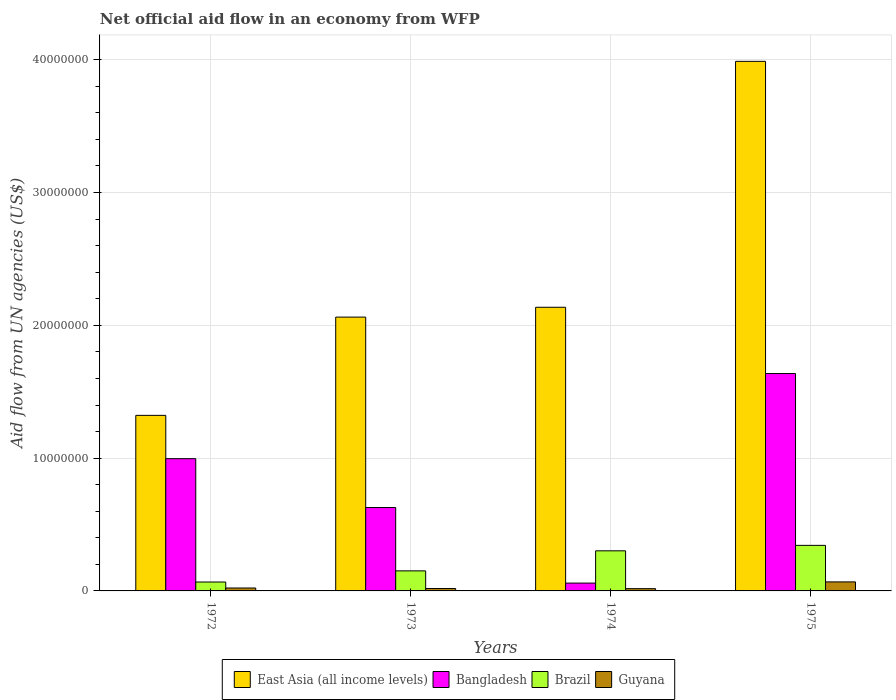Are the number of bars per tick equal to the number of legend labels?
Offer a terse response. Yes. In how many cases, is the number of bars for a given year not equal to the number of legend labels?
Keep it short and to the point. 0. What is the net official aid flow in Bangladesh in 1973?
Provide a succinct answer. 6.28e+06. Across all years, what is the maximum net official aid flow in Guyana?
Ensure brevity in your answer.  6.80e+05. Across all years, what is the minimum net official aid flow in Bangladesh?
Your answer should be very brief. 5.90e+05. In which year was the net official aid flow in Guyana maximum?
Offer a terse response. 1975. In which year was the net official aid flow in Bangladesh minimum?
Your answer should be compact. 1974. What is the total net official aid flow in Guyana in the graph?
Keep it short and to the point. 1.25e+06. What is the difference between the net official aid flow in Guyana in 1972 and that in 1973?
Give a very brief answer. 4.00e+04. What is the difference between the net official aid flow in East Asia (all income levels) in 1975 and the net official aid flow in Brazil in 1972?
Provide a short and direct response. 3.92e+07. What is the average net official aid flow in Bangladesh per year?
Keep it short and to the point. 8.30e+06. In the year 1975, what is the difference between the net official aid flow in East Asia (all income levels) and net official aid flow in Bangladesh?
Your answer should be very brief. 2.35e+07. In how many years, is the net official aid flow in East Asia (all income levels) greater than 38000000 US$?
Make the answer very short. 1. What is the ratio of the net official aid flow in East Asia (all income levels) in 1972 to that in 1975?
Make the answer very short. 0.33. Is the net official aid flow in Brazil in 1972 less than that in 1975?
Your answer should be compact. Yes. Is the difference between the net official aid flow in East Asia (all income levels) in 1972 and 1975 greater than the difference between the net official aid flow in Bangladesh in 1972 and 1975?
Keep it short and to the point. No. What is the difference between the highest and the second highest net official aid flow in Guyana?
Offer a very short reply. 4.60e+05. What is the difference between the highest and the lowest net official aid flow in Guyana?
Ensure brevity in your answer.  5.10e+05. In how many years, is the net official aid flow in Bangladesh greater than the average net official aid flow in Bangladesh taken over all years?
Ensure brevity in your answer.  2. What does the 4th bar from the left in 1973 represents?
Give a very brief answer. Guyana. What does the 1st bar from the right in 1972 represents?
Your answer should be very brief. Guyana. Are all the bars in the graph horizontal?
Offer a terse response. No. How many years are there in the graph?
Your answer should be compact. 4. What is the difference between two consecutive major ticks on the Y-axis?
Your response must be concise. 1.00e+07. Are the values on the major ticks of Y-axis written in scientific E-notation?
Provide a short and direct response. No. How many legend labels are there?
Your answer should be compact. 4. What is the title of the graph?
Your answer should be compact. Net official aid flow in an economy from WFP. Does "Singapore" appear as one of the legend labels in the graph?
Your answer should be very brief. No. What is the label or title of the Y-axis?
Offer a terse response. Aid flow from UN agencies (US$). What is the Aid flow from UN agencies (US$) of East Asia (all income levels) in 1972?
Offer a very short reply. 1.32e+07. What is the Aid flow from UN agencies (US$) in Bangladesh in 1972?
Your answer should be very brief. 9.96e+06. What is the Aid flow from UN agencies (US$) in Brazil in 1972?
Your response must be concise. 6.70e+05. What is the Aid flow from UN agencies (US$) in East Asia (all income levels) in 1973?
Offer a terse response. 2.06e+07. What is the Aid flow from UN agencies (US$) in Bangladesh in 1973?
Make the answer very short. 6.28e+06. What is the Aid flow from UN agencies (US$) in Brazil in 1973?
Provide a succinct answer. 1.51e+06. What is the Aid flow from UN agencies (US$) of Guyana in 1973?
Offer a very short reply. 1.80e+05. What is the Aid flow from UN agencies (US$) of East Asia (all income levels) in 1974?
Your response must be concise. 2.14e+07. What is the Aid flow from UN agencies (US$) in Bangladesh in 1974?
Make the answer very short. 5.90e+05. What is the Aid flow from UN agencies (US$) of Brazil in 1974?
Your answer should be compact. 3.02e+06. What is the Aid flow from UN agencies (US$) in Guyana in 1974?
Provide a succinct answer. 1.70e+05. What is the Aid flow from UN agencies (US$) in East Asia (all income levels) in 1975?
Keep it short and to the point. 3.99e+07. What is the Aid flow from UN agencies (US$) of Bangladesh in 1975?
Offer a very short reply. 1.64e+07. What is the Aid flow from UN agencies (US$) of Brazil in 1975?
Give a very brief answer. 3.43e+06. What is the Aid flow from UN agencies (US$) of Guyana in 1975?
Ensure brevity in your answer.  6.80e+05. Across all years, what is the maximum Aid flow from UN agencies (US$) in East Asia (all income levels)?
Your response must be concise. 3.99e+07. Across all years, what is the maximum Aid flow from UN agencies (US$) of Bangladesh?
Your answer should be compact. 1.64e+07. Across all years, what is the maximum Aid flow from UN agencies (US$) in Brazil?
Make the answer very short. 3.43e+06. Across all years, what is the maximum Aid flow from UN agencies (US$) of Guyana?
Provide a short and direct response. 6.80e+05. Across all years, what is the minimum Aid flow from UN agencies (US$) of East Asia (all income levels)?
Keep it short and to the point. 1.32e+07. Across all years, what is the minimum Aid flow from UN agencies (US$) in Bangladesh?
Provide a succinct answer. 5.90e+05. Across all years, what is the minimum Aid flow from UN agencies (US$) in Brazil?
Provide a succinct answer. 6.70e+05. What is the total Aid flow from UN agencies (US$) in East Asia (all income levels) in the graph?
Keep it short and to the point. 9.51e+07. What is the total Aid flow from UN agencies (US$) of Bangladesh in the graph?
Your answer should be compact. 3.32e+07. What is the total Aid flow from UN agencies (US$) in Brazil in the graph?
Keep it short and to the point. 8.63e+06. What is the total Aid flow from UN agencies (US$) of Guyana in the graph?
Make the answer very short. 1.25e+06. What is the difference between the Aid flow from UN agencies (US$) in East Asia (all income levels) in 1972 and that in 1973?
Provide a short and direct response. -7.40e+06. What is the difference between the Aid flow from UN agencies (US$) in Bangladesh in 1972 and that in 1973?
Your answer should be very brief. 3.68e+06. What is the difference between the Aid flow from UN agencies (US$) of Brazil in 1972 and that in 1973?
Make the answer very short. -8.40e+05. What is the difference between the Aid flow from UN agencies (US$) in Guyana in 1972 and that in 1973?
Your answer should be very brief. 4.00e+04. What is the difference between the Aid flow from UN agencies (US$) in East Asia (all income levels) in 1972 and that in 1974?
Your response must be concise. -8.14e+06. What is the difference between the Aid flow from UN agencies (US$) of Bangladesh in 1972 and that in 1974?
Offer a terse response. 9.37e+06. What is the difference between the Aid flow from UN agencies (US$) of Brazil in 1972 and that in 1974?
Keep it short and to the point. -2.35e+06. What is the difference between the Aid flow from UN agencies (US$) in East Asia (all income levels) in 1972 and that in 1975?
Give a very brief answer. -2.67e+07. What is the difference between the Aid flow from UN agencies (US$) in Bangladesh in 1972 and that in 1975?
Keep it short and to the point. -6.41e+06. What is the difference between the Aid flow from UN agencies (US$) of Brazil in 1972 and that in 1975?
Offer a very short reply. -2.76e+06. What is the difference between the Aid flow from UN agencies (US$) in Guyana in 1972 and that in 1975?
Give a very brief answer. -4.60e+05. What is the difference between the Aid flow from UN agencies (US$) in East Asia (all income levels) in 1973 and that in 1974?
Your response must be concise. -7.40e+05. What is the difference between the Aid flow from UN agencies (US$) of Bangladesh in 1973 and that in 1974?
Your response must be concise. 5.69e+06. What is the difference between the Aid flow from UN agencies (US$) in Brazil in 1973 and that in 1974?
Provide a succinct answer. -1.51e+06. What is the difference between the Aid flow from UN agencies (US$) of Guyana in 1973 and that in 1974?
Make the answer very short. 10000. What is the difference between the Aid flow from UN agencies (US$) in East Asia (all income levels) in 1973 and that in 1975?
Offer a terse response. -1.93e+07. What is the difference between the Aid flow from UN agencies (US$) of Bangladesh in 1973 and that in 1975?
Your answer should be very brief. -1.01e+07. What is the difference between the Aid flow from UN agencies (US$) in Brazil in 1973 and that in 1975?
Your response must be concise. -1.92e+06. What is the difference between the Aid flow from UN agencies (US$) in Guyana in 1973 and that in 1975?
Offer a terse response. -5.00e+05. What is the difference between the Aid flow from UN agencies (US$) of East Asia (all income levels) in 1974 and that in 1975?
Offer a very short reply. -1.85e+07. What is the difference between the Aid flow from UN agencies (US$) of Bangladesh in 1974 and that in 1975?
Provide a short and direct response. -1.58e+07. What is the difference between the Aid flow from UN agencies (US$) of Brazil in 1974 and that in 1975?
Ensure brevity in your answer.  -4.10e+05. What is the difference between the Aid flow from UN agencies (US$) in Guyana in 1974 and that in 1975?
Your answer should be compact. -5.10e+05. What is the difference between the Aid flow from UN agencies (US$) of East Asia (all income levels) in 1972 and the Aid flow from UN agencies (US$) of Bangladesh in 1973?
Give a very brief answer. 6.94e+06. What is the difference between the Aid flow from UN agencies (US$) of East Asia (all income levels) in 1972 and the Aid flow from UN agencies (US$) of Brazil in 1973?
Your response must be concise. 1.17e+07. What is the difference between the Aid flow from UN agencies (US$) in East Asia (all income levels) in 1972 and the Aid flow from UN agencies (US$) in Guyana in 1973?
Your answer should be very brief. 1.30e+07. What is the difference between the Aid flow from UN agencies (US$) of Bangladesh in 1972 and the Aid flow from UN agencies (US$) of Brazil in 1973?
Provide a short and direct response. 8.45e+06. What is the difference between the Aid flow from UN agencies (US$) in Bangladesh in 1972 and the Aid flow from UN agencies (US$) in Guyana in 1973?
Offer a very short reply. 9.78e+06. What is the difference between the Aid flow from UN agencies (US$) in East Asia (all income levels) in 1972 and the Aid flow from UN agencies (US$) in Bangladesh in 1974?
Your answer should be compact. 1.26e+07. What is the difference between the Aid flow from UN agencies (US$) of East Asia (all income levels) in 1972 and the Aid flow from UN agencies (US$) of Brazil in 1974?
Your response must be concise. 1.02e+07. What is the difference between the Aid flow from UN agencies (US$) in East Asia (all income levels) in 1972 and the Aid flow from UN agencies (US$) in Guyana in 1974?
Keep it short and to the point. 1.30e+07. What is the difference between the Aid flow from UN agencies (US$) of Bangladesh in 1972 and the Aid flow from UN agencies (US$) of Brazil in 1974?
Give a very brief answer. 6.94e+06. What is the difference between the Aid flow from UN agencies (US$) in Bangladesh in 1972 and the Aid flow from UN agencies (US$) in Guyana in 1974?
Offer a terse response. 9.79e+06. What is the difference between the Aid flow from UN agencies (US$) in Brazil in 1972 and the Aid flow from UN agencies (US$) in Guyana in 1974?
Ensure brevity in your answer.  5.00e+05. What is the difference between the Aid flow from UN agencies (US$) in East Asia (all income levels) in 1972 and the Aid flow from UN agencies (US$) in Bangladesh in 1975?
Provide a succinct answer. -3.15e+06. What is the difference between the Aid flow from UN agencies (US$) in East Asia (all income levels) in 1972 and the Aid flow from UN agencies (US$) in Brazil in 1975?
Keep it short and to the point. 9.79e+06. What is the difference between the Aid flow from UN agencies (US$) of East Asia (all income levels) in 1972 and the Aid flow from UN agencies (US$) of Guyana in 1975?
Your answer should be compact. 1.25e+07. What is the difference between the Aid flow from UN agencies (US$) in Bangladesh in 1972 and the Aid flow from UN agencies (US$) in Brazil in 1975?
Your answer should be very brief. 6.53e+06. What is the difference between the Aid flow from UN agencies (US$) in Bangladesh in 1972 and the Aid flow from UN agencies (US$) in Guyana in 1975?
Your answer should be compact. 9.28e+06. What is the difference between the Aid flow from UN agencies (US$) in Brazil in 1972 and the Aid flow from UN agencies (US$) in Guyana in 1975?
Make the answer very short. -10000. What is the difference between the Aid flow from UN agencies (US$) of East Asia (all income levels) in 1973 and the Aid flow from UN agencies (US$) of Bangladesh in 1974?
Provide a short and direct response. 2.00e+07. What is the difference between the Aid flow from UN agencies (US$) in East Asia (all income levels) in 1973 and the Aid flow from UN agencies (US$) in Brazil in 1974?
Provide a succinct answer. 1.76e+07. What is the difference between the Aid flow from UN agencies (US$) in East Asia (all income levels) in 1973 and the Aid flow from UN agencies (US$) in Guyana in 1974?
Provide a succinct answer. 2.04e+07. What is the difference between the Aid flow from UN agencies (US$) in Bangladesh in 1973 and the Aid flow from UN agencies (US$) in Brazil in 1974?
Provide a short and direct response. 3.26e+06. What is the difference between the Aid flow from UN agencies (US$) of Bangladesh in 1973 and the Aid flow from UN agencies (US$) of Guyana in 1974?
Provide a short and direct response. 6.11e+06. What is the difference between the Aid flow from UN agencies (US$) of Brazil in 1973 and the Aid flow from UN agencies (US$) of Guyana in 1974?
Your response must be concise. 1.34e+06. What is the difference between the Aid flow from UN agencies (US$) of East Asia (all income levels) in 1973 and the Aid flow from UN agencies (US$) of Bangladesh in 1975?
Keep it short and to the point. 4.25e+06. What is the difference between the Aid flow from UN agencies (US$) of East Asia (all income levels) in 1973 and the Aid flow from UN agencies (US$) of Brazil in 1975?
Offer a very short reply. 1.72e+07. What is the difference between the Aid flow from UN agencies (US$) in East Asia (all income levels) in 1973 and the Aid flow from UN agencies (US$) in Guyana in 1975?
Keep it short and to the point. 1.99e+07. What is the difference between the Aid flow from UN agencies (US$) in Bangladesh in 1973 and the Aid flow from UN agencies (US$) in Brazil in 1975?
Your answer should be very brief. 2.85e+06. What is the difference between the Aid flow from UN agencies (US$) of Bangladesh in 1973 and the Aid flow from UN agencies (US$) of Guyana in 1975?
Your response must be concise. 5.60e+06. What is the difference between the Aid flow from UN agencies (US$) in Brazil in 1973 and the Aid flow from UN agencies (US$) in Guyana in 1975?
Your answer should be very brief. 8.30e+05. What is the difference between the Aid flow from UN agencies (US$) of East Asia (all income levels) in 1974 and the Aid flow from UN agencies (US$) of Bangladesh in 1975?
Your answer should be very brief. 4.99e+06. What is the difference between the Aid flow from UN agencies (US$) in East Asia (all income levels) in 1974 and the Aid flow from UN agencies (US$) in Brazil in 1975?
Make the answer very short. 1.79e+07. What is the difference between the Aid flow from UN agencies (US$) in East Asia (all income levels) in 1974 and the Aid flow from UN agencies (US$) in Guyana in 1975?
Keep it short and to the point. 2.07e+07. What is the difference between the Aid flow from UN agencies (US$) in Bangladesh in 1974 and the Aid flow from UN agencies (US$) in Brazil in 1975?
Make the answer very short. -2.84e+06. What is the difference between the Aid flow from UN agencies (US$) in Brazil in 1974 and the Aid flow from UN agencies (US$) in Guyana in 1975?
Make the answer very short. 2.34e+06. What is the average Aid flow from UN agencies (US$) of East Asia (all income levels) per year?
Make the answer very short. 2.38e+07. What is the average Aid flow from UN agencies (US$) in Bangladesh per year?
Ensure brevity in your answer.  8.30e+06. What is the average Aid flow from UN agencies (US$) of Brazil per year?
Your answer should be compact. 2.16e+06. What is the average Aid flow from UN agencies (US$) in Guyana per year?
Provide a succinct answer. 3.12e+05. In the year 1972, what is the difference between the Aid flow from UN agencies (US$) of East Asia (all income levels) and Aid flow from UN agencies (US$) of Bangladesh?
Provide a succinct answer. 3.26e+06. In the year 1972, what is the difference between the Aid flow from UN agencies (US$) of East Asia (all income levels) and Aid flow from UN agencies (US$) of Brazil?
Make the answer very short. 1.26e+07. In the year 1972, what is the difference between the Aid flow from UN agencies (US$) in East Asia (all income levels) and Aid flow from UN agencies (US$) in Guyana?
Your answer should be very brief. 1.30e+07. In the year 1972, what is the difference between the Aid flow from UN agencies (US$) in Bangladesh and Aid flow from UN agencies (US$) in Brazil?
Keep it short and to the point. 9.29e+06. In the year 1972, what is the difference between the Aid flow from UN agencies (US$) of Bangladesh and Aid flow from UN agencies (US$) of Guyana?
Provide a succinct answer. 9.74e+06. In the year 1972, what is the difference between the Aid flow from UN agencies (US$) in Brazil and Aid flow from UN agencies (US$) in Guyana?
Give a very brief answer. 4.50e+05. In the year 1973, what is the difference between the Aid flow from UN agencies (US$) in East Asia (all income levels) and Aid flow from UN agencies (US$) in Bangladesh?
Your response must be concise. 1.43e+07. In the year 1973, what is the difference between the Aid flow from UN agencies (US$) of East Asia (all income levels) and Aid flow from UN agencies (US$) of Brazil?
Your response must be concise. 1.91e+07. In the year 1973, what is the difference between the Aid flow from UN agencies (US$) in East Asia (all income levels) and Aid flow from UN agencies (US$) in Guyana?
Offer a terse response. 2.04e+07. In the year 1973, what is the difference between the Aid flow from UN agencies (US$) in Bangladesh and Aid flow from UN agencies (US$) in Brazil?
Your answer should be compact. 4.77e+06. In the year 1973, what is the difference between the Aid flow from UN agencies (US$) of Bangladesh and Aid flow from UN agencies (US$) of Guyana?
Give a very brief answer. 6.10e+06. In the year 1973, what is the difference between the Aid flow from UN agencies (US$) of Brazil and Aid flow from UN agencies (US$) of Guyana?
Provide a succinct answer. 1.33e+06. In the year 1974, what is the difference between the Aid flow from UN agencies (US$) in East Asia (all income levels) and Aid flow from UN agencies (US$) in Bangladesh?
Ensure brevity in your answer.  2.08e+07. In the year 1974, what is the difference between the Aid flow from UN agencies (US$) in East Asia (all income levels) and Aid flow from UN agencies (US$) in Brazil?
Give a very brief answer. 1.83e+07. In the year 1974, what is the difference between the Aid flow from UN agencies (US$) in East Asia (all income levels) and Aid flow from UN agencies (US$) in Guyana?
Give a very brief answer. 2.12e+07. In the year 1974, what is the difference between the Aid flow from UN agencies (US$) of Bangladesh and Aid flow from UN agencies (US$) of Brazil?
Ensure brevity in your answer.  -2.43e+06. In the year 1974, what is the difference between the Aid flow from UN agencies (US$) in Brazil and Aid flow from UN agencies (US$) in Guyana?
Provide a succinct answer. 2.85e+06. In the year 1975, what is the difference between the Aid flow from UN agencies (US$) in East Asia (all income levels) and Aid flow from UN agencies (US$) in Bangladesh?
Offer a very short reply. 2.35e+07. In the year 1975, what is the difference between the Aid flow from UN agencies (US$) of East Asia (all income levels) and Aid flow from UN agencies (US$) of Brazil?
Your response must be concise. 3.64e+07. In the year 1975, what is the difference between the Aid flow from UN agencies (US$) in East Asia (all income levels) and Aid flow from UN agencies (US$) in Guyana?
Offer a very short reply. 3.92e+07. In the year 1975, what is the difference between the Aid flow from UN agencies (US$) of Bangladesh and Aid flow from UN agencies (US$) of Brazil?
Provide a succinct answer. 1.29e+07. In the year 1975, what is the difference between the Aid flow from UN agencies (US$) of Bangladesh and Aid flow from UN agencies (US$) of Guyana?
Your answer should be very brief. 1.57e+07. In the year 1975, what is the difference between the Aid flow from UN agencies (US$) in Brazil and Aid flow from UN agencies (US$) in Guyana?
Make the answer very short. 2.75e+06. What is the ratio of the Aid flow from UN agencies (US$) of East Asia (all income levels) in 1972 to that in 1973?
Your response must be concise. 0.64. What is the ratio of the Aid flow from UN agencies (US$) in Bangladesh in 1972 to that in 1973?
Give a very brief answer. 1.59. What is the ratio of the Aid flow from UN agencies (US$) in Brazil in 1972 to that in 1973?
Offer a very short reply. 0.44. What is the ratio of the Aid flow from UN agencies (US$) of Guyana in 1972 to that in 1973?
Keep it short and to the point. 1.22. What is the ratio of the Aid flow from UN agencies (US$) of East Asia (all income levels) in 1972 to that in 1974?
Make the answer very short. 0.62. What is the ratio of the Aid flow from UN agencies (US$) in Bangladesh in 1972 to that in 1974?
Provide a short and direct response. 16.88. What is the ratio of the Aid flow from UN agencies (US$) of Brazil in 1972 to that in 1974?
Provide a succinct answer. 0.22. What is the ratio of the Aid flow from UN agencies (US$) in Guyana in 1972 to that in 1974?
Ensure brevity in your answer.  1.29. What is the ratio of the Aid flow from UN agencies (US$) of East Asia (all income levels) in 1972 to that in 1975?
Make the answer very short. 0.33. What is the ratio of the Aid flow from UN agencies (US$) of Bangladesh in 1972 to that in 1975?
Ensure brevity in your answer.  0.61. What is the ratio of the Aid flow from UN agencies (US$) in Brazil in 1972 to that in 1975?
Offer a terse response. 0.2. What is the ratio of the Aid flow from UN agencies (US$) of Guyana in 1972 to that in 1975?
Your response must be concise. 0.32. What is the ratio of the Aid flow from UN agencies (US$) of East Asia (all income levels) in 1973 to that in 1974?
Provide a short and direct response. 0.97. What is the ratio of the Aid flow from UN agencies (US$) in Bangladesh in 1973 to that in 1974?
Your response must be concise. 10.64. What is the ratio of the Aid flow from UN agencies (US$) in Guyana in 1973 to that in 1974?
Offer a terse response. 1.06. What is the ratio of the Aid flow from UN agencies (US$) of East Asia (all income levels) in 1973 to that in 1975?
Keep it short and to the point. 0.52. What is the ratio of the Aid flow from UN agencies (US$) in Bangladesh in 1973 to that in 1975?
Make the answer very short. 0.38. What is the ratio of the Aid flow from UN agencies (US$) in Brazil in 1973 to that in 1975?
Your response must be concise. 0.44. What is the ratio of the Aid flow from UN agencies (US$) in Guyana in 1973 to that in 1975?
Make the answer very short. 0.26. What is the ratio of the Aid flow from UN agencies (US$) of East Asia (all income levels) in 1974 to that in 1975?
Your response must be concise. 0.54. What is the ratio of the Aid flow from UN agencies (US$) of Bangladesh in 1974 to that in 1975?
Ensure brevity in your answer.  0.04. What is the ratio of the Aid flow from UN agencies (US$) of Brazil in 1974 to that in 1975?
Offer a terse response. 0.88. What is the ratio of the Aid flow from UN agencies (US$) in Guyana in 1974 to that in 1975?
Give a very brief answer. 0.25. What is the difference between the highest and the second highest Aid flow from UN agencies (US$) in East Asia (all income levels)?
Your answer should be compact. 1.85e+07. What is the difference between the highest and the second highest Aid flow from UN agencies (US$) of Bangladesh?
Make the answer very short. 6.41e+06. What is the difference between the highest and the lowest Aid flow from UN agencies (US$) in East Asia (all income levels)?
Keep it short and to the point. 2.67e+07. What is the difference between the highest and the lowest Aid flow from UN agencies (US$) of Bangladesh?
Provide a succinct answer. 1.58e+07. What is the difference between the highest and the lowest Aid flow from UN agencies (US$) of Brazil?
Provide a succinct answer. 2.76e+06. What is the difference between the highest and the lowest Aid flow from UN agencies (US$) in Guyana?
Ensure brevity in your answer.  5.10e+05. 